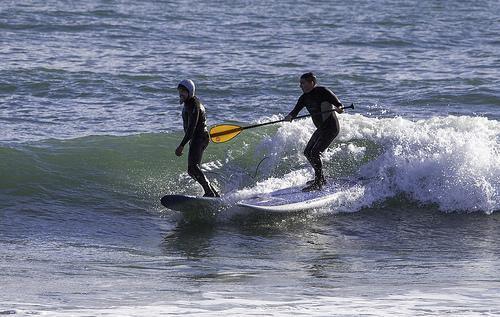How many surfboards in this picture?
Give a very brief answer. 2. 